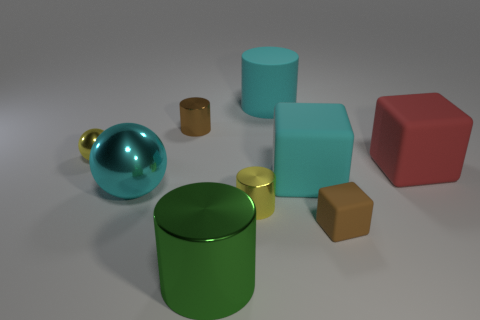Subtract 1 cylinders. How many cylinders are left? 3 Subtract all red cylinders. Subtract all green cubes. How many cylinders are left? 4 Add 1 big cyan rubber cubes. How many objects exist? 10 Subtract all cylinders. How many objects are left? 5 Add 5 large yellow rubber cylinders. How many large yellow rubber cylinders exist? 5 Subtract 1 cyan cylinders. How many objects are left? 8 Subtract all cyan things. Subtract all blocks. How many objects are left? 3 Add 3 large cyan blocks. How many large cyan blocks are left? 4 